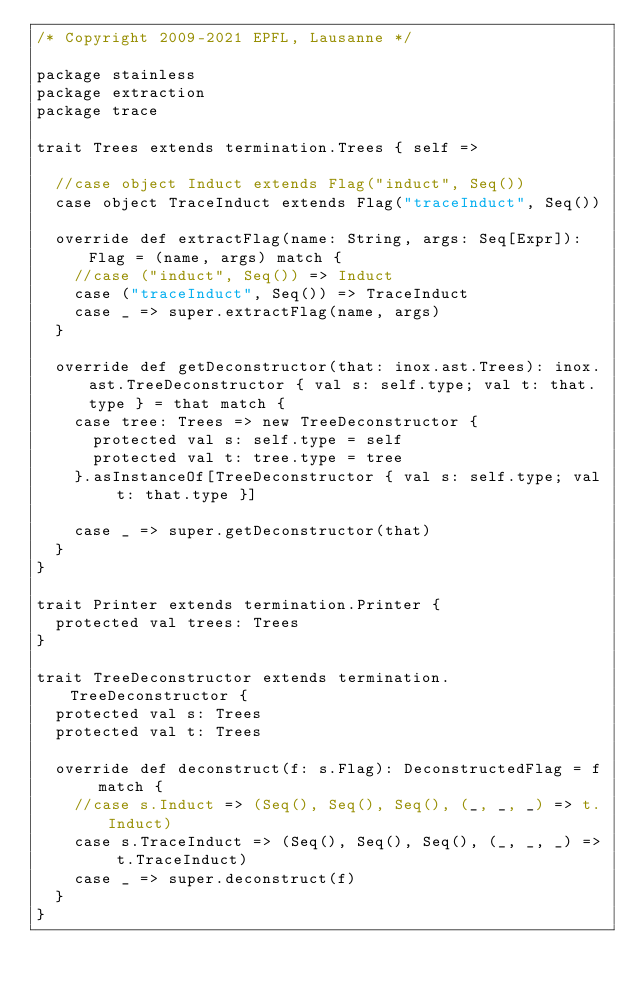<code> <loc_0><loc_0><loc_500><loc_500><_Scala_>/* Copyright 2009-2021 EPFL, Lausanne */

package stainless
package extraction
package trace

trait Trees extends termination.Trees { self =>

  //case object Induct extends Flag("induct", Seq())
  case object TraceInduct extends Flag("traceInduct", Seq())

  override def extractFlag(name: String, args: Seq[Expr]): Flag = (name, args) match {
    //case ("induct", Seq()) => Induct
    case ("traceInduct", Seq()) => TraceInduct
    case _ => super.extractFlag(name, args)
  }

  override def getDeconstructor(that: inox.ast.Trees): inox.ast.TreeDeconstructor { val s: self.type; val t: that.type } = that match {
    case tree: Trees => new TreeDeconstructor {
      protected val s: self.type = self
      protected val t: tree.type = tree
    }.asInstanceOf[TreeDeconstructor { val s: self.type; val t: that.type }]

    case _ => super.getDeconstructor(that)
  }
}

trait Printer extends termination.Printer {
  protected val trees: Trees
}

trait TreeDeconstructor extends termination.TreeDeconstructor {
  protected val s: Trees
  protected val t: Trees

  override def deconstruct(f: s.Flag): DeconstructedFlag = f match {
    //case s.Induct => (Seq(), Seq(), Seq(), (_, _, _) => t.Induct)
    case s.TraceInduct => (Seq(), Seq(), Seq(), (_, _, _) => t.TraceInduct)
    case _ => super.deconstruct(f)
  }
}</code> 